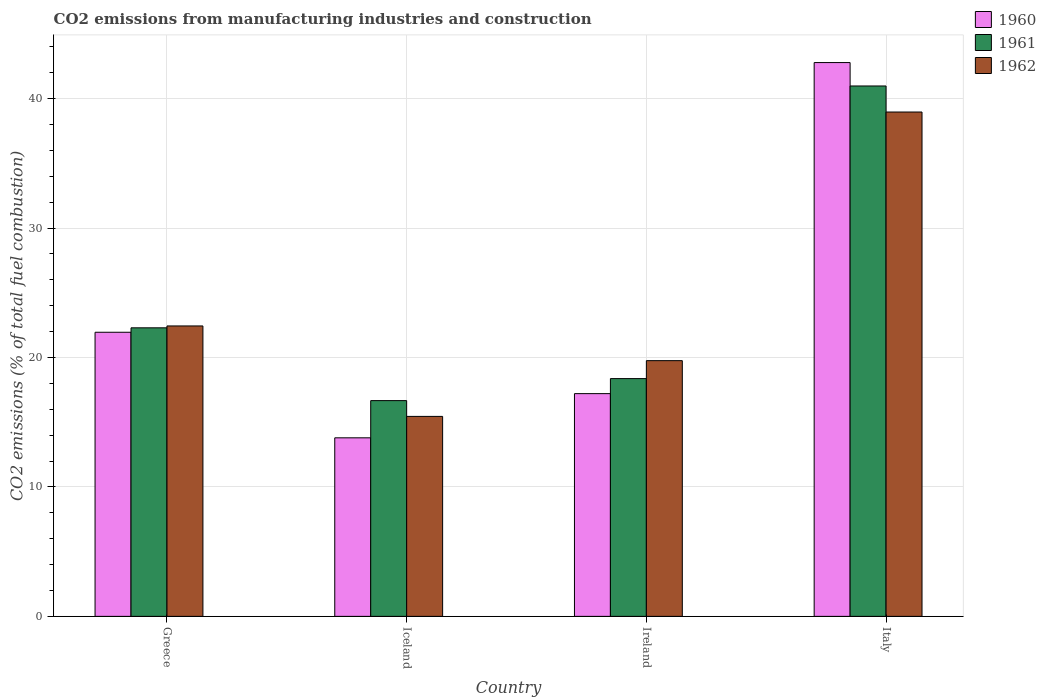How many different coloured bars are there?
Your answer should be very brief. 3. Are the number of bars per tick equal to the number of legend labels?
Give a very brief answer. Yes. Are the number of bars on each tick of the X-axis equal?
Your answer should be very brief. Yes. What is the label of the 2nd group of bars from the left?
Give a very brief answer. Iceland. What is the amount of CO2 emitted in 1960 in Greece?
Your answer should be very brief. 21.95. Across all countries, what is the maximum amount of CO2 emitted in 1960?
Keep it short and to the point. 42.78. Across all countries, what is the minimum amount of CO2 emitted in 1961?
Keep it short and to the point. 16.67. In which country was the amount of CO2 emitted in 1960 maximum?
Keep it short and to the point. Italy. In which country was the amount of CO2 emitted in 1962 minimum?
Your response must be concise. Iceland. What is the total amount of CO2 emitted in 1960 in the graph?
Ensure brevity in your answer.  95.73. What is the difference between the amount of CO2 emitted in 1960 in Iceland and that in Italy?
Make the answer very short. -28.99. What is the difference between the amount of CO2 emitted in 1960 in Italy and the amount of CO2 emitted in 1961 in Iceland?
Provide a succinct answer. 26.12. What is the average amount of CO2 emitted in 1961 per country?
Offer a terse response. 24.57. What is the difference between the amount of CO2 emitted of/in 1961 and amount of CO2 emitted of/in 1960 in Greece?
Your answer should be very brief. 0.34. What is the ratio of the amount of CO2 emitted in 1962 in Greece to that in Italy?
Keep it short and to the point. 0.58. Is the amount of CO2 emitted in 1962 in Ireland less than that in Italy?
Your answer should be very brief. Yes. Is the difference between the amount of CO2 emitted in 1961 in Greece and Italy greater than the difference between the amount of CO2 emitted in 1960 in Greece and Italy?
Your response must be concise. Yes. What is the difference between the highest and the second highest amount of CO2 emitted in 1961?
Offer a very short reply. 22.61. What is the difference between the highest and the lowest amount of CO2 emitted in 1962?
Offer a terse response. 23.51. Is the sum of the amount of CO2 emitted in 1961 in Greece and Iceland greater than the maximum amount of CO2 emitted in 1960 across all countries?
Ensure brevity in your answer.  No. What does the 3rd bar from the left in Ireland represents?
Your answer should be compact. 1962. How many bars are there?
Make the answer very short. 12. Are all the bars in the graph horizontal?
Offer a very short reply. No. Does the graph contain grids?
Offer a very short reply. Yes. Where does the legend appear in the graph?
Offer a very short reply. Top right. How many legend labels are there?
Ensure brevity in your answer.  3. How are the legend labels stacked?
Your response must be concise. Vertical. What is the title of the graph?
Your answer should be compact. CO2 emissions from manufacturing industries and construction. Does "2011" appear as one of the legend labels in the graph?
Your response must be concise. No. What is the label or title of the Y-axis?
Offer a very short reply. CO2 emissions (% of total fuel combustion). What is the CO2 emissions (% of total fuel combustion) of 1960 in Greece?
Your answer should be very brief. 21.95. What is the CO2 emissions (% of total fuel combustion) in 1961 in Greece?
Make the answer very short. 22.29. What is the CO2 emissions (% of total fuel combustion) in 1962 in Greece?
Ensure brevity in your answer.  22.44. What is the CO2 emissions (% of total fuel combustion) in 1960 in Iceland?
Your answer should be compact. 13.79. What is the CO2 emissions (% of total fuel combustion) of 1961 in Iceland?
Give a very brief answer. 16.67. What is the CO2 emissions (% of total fuel combustion) in 1962 in Iceland?
Provide a short and direct response. 15.45. What is the CO2 emissions (% of total fuel combustion) in 1960 in Ireland?
Offer a very short reply. 17.21. What is the CO2 emissions (% of total fuel combustion) in 1961 in Ireland?
Ensure brevity in your answer.  18.37. What is the CO2 emissions (% of total fuel combustion) in 1962 in Ireland?
Your response must be concise. 19.75. What is the CO2 emissions (% of total fuel combustion) of 1960 in Italy?
Make the answer very short. 42.78. What is the CO2 emissions (% of total fuel combustion) of 1961 in Italy?
Provide a short and direct response. 40.97. What is the CO2 emissions (% of total fuel combustion) of 1962 in Italy?
Ensure brevity in your answer.  38.96. Across all countries, what is the maximum CO2 emissions (% of total fuel combustion) of 1960?
Offer a terse response. 42.78. Across all countries, what is the maximum CO2 emissions (% of total fuel combustion) of 1961?
Provide a succinct answer. 40.97. Across all countries, what is the maximum CO2 emissions (% of total fuel combustion) of 1962?
Give a very brief answer. 38.96. Across all countries, what is the minimum CO2 emissions (% of total fuel combustion) in 1960?
Offer a very short reply. 13.79. Across all countries, what is the minimum CO2 emissions (% of total fuel combustion) in 1961?
Your answer should be very brief. 16.67. Across all countries, what is the minimum CO2 emissions (% of total fuel combustion) in 1962?
Keep it short and to the point. 15.45. What is the total CO2 emissions (% of total fuel combustion) in 1960 in the graph?
Your response must be concise. 95.73. What is the total CO2 emissions (% of total fuel combustion) in 1961 in the graph?
Offer a terse response. 98.3. What is the total CO2 emissions (% of total fuel combustion) of 1962 in the graph?
Your answer should be compact. 96.6. What is the difference between the CO2 emissions (% of total fuel combustion) of 1960 in Greece and that in Iceland?
Your response must be concise. 8.15. What is the difference between the CO2 emissions (% of total fuel combustion) in 1961 in Greece and that in Iceland?
Your response must be concise. 5.62. What is the difference between the CO2 emissions (% of total fuel combustion) in 1962 in Greece and that in Iceland?
Your answer should be very brief. 6.99. What is the difference between the CO2 emissions (% of total fuel combustion) in 1960 in Greece and that in Ireland?
Provide a short and direct response. 4.74. What is the difference between the CO2 emissions (% of total fuel combustion) in 1961 in Greece and that in Ireland?
Offer a terse response. 3.92. What is the difference between the CO2 emissions (% of total fuel combustion) in 1962 in Greece and that in Ireland?
Offer a terse response. 2.68. What is the difference between the CO2 emissions (% of total fuel combustion) of 1960 in Greece and that in Italy?
Your answer should be very brief. -20.83. What is the difference between the CO2 emissions (% of total fuel combustion) of 1961 in Greece and that in Italy?
Provide a succinct answer. -18.68. What is the difference between the CO2 emissions (% of total fuel combustion) of 1962 in Greece and that in Italy?
Your response must be concise. -16.53. What is the difference between the CO2 emissions (% of total fuel combustion) of 1960 in Iceland and that in Ireland?
Your response must be concise. -3.41. What is the difference between the CO2 emissions (% of total fuel combustion) in 1961 in Iceland and that in Ireland?
Ensure brevity in your answer.  -1.7. What is the difference between the CO2 emissions (% of total fuel combustion) of 1962 in Iceland and that in Ireland?
Provide a short and direct response. -4.31. What is the difference between the CO2 emissions (% of total fuel combustion) in 1960 in Iceland and that in Italy?
Your answer should be very brief. -28.99. What is the difference between the CO2 emissions (% of total fuel combustion) of 1961 in Iceland and that in Italy?
Your response must be concise. -24.31. What is the difference between the CO2 emissions (% of total fuel combustion) of 1962 in Iceland and that in Italy?
Keep it short and to the point. -23.51. What is the difference between the CO2 emissions (% of total fuel combustion) of 1960 in Ireland and that in Italy?
Your answer should be very brief. -25.57. What is the difference between the CO2 emissions (% of total fuel combustion) of 1961 in Ireland and that in Italy?
Your response must be concise. -22.61. What is the difference between the CO2 emissions (% of total fuel combustion) of 1962 in Ireland and that in Italy?
Your answer should be compact. -19.21. What is the difference between the CO2 emissions (% of total fuel combustion) of 1960 in Greece and the CO2 emissions (% of total fuel combustion) of 1961 in Iceland?
Offer a terse response. 5.28. What is the difference between the CO2 emissions (% of total fuel combustion) of 1960 in Greece and the CO2 emissions (% of total fuel combustion) of 1962 in Iceland?
Make the answer very short. 6.5. What is the difference between the CO2 emissions (% of total fuel combustion) of 1961 in Greece and the CO2 emissions (% of total fuel combustion) of 1962 in Iceland?
Your answer should be very brief. 6.84. What is the difference between the CO2 emissions (% of total fuel combustion) in 1960 in Greece and the CO2 emissions (% of total fuel combustion) in 1961 in Ireland?
Your answer should be very brief. 3.58. What is the difference between the CO2 emissions (% of total fuel combustion) of 1960 in Greece and the CO2 emissions (% of total fuel combustion) of 1962 in Ireland?
Offer a very short reply. 2.19. What is the difference between the CO2 emissions (% of total fuel combustion) of 1961 in Greece and the CO2 emissions (% of total fuel combustion) of 1962 in Ireland?
Give a very brief answer. 2.54. What is the difference between the CO2 emissions (% of total fuel combustion) in 1960 in Greece and the CO2 emissions (% of total fuel combustion) in 1961 in Italy?
Provide a succinct answer. -19.03. What is the difference between the CO2 emissions (% of total fuel combustion) in 1960 in Greece and the CO2 emissions (% of total fuel combustion) in 1962 in Italy?
Offer a very short reply. -17.01. What is the difference between the CO2 emissions (% of total fuel combustion) in 1961 in Greece and the CO2 emissions (% of total fuel combustion) in 1962 in Italy?
Give a very brief answer. -16.67. What is the difference between the CO2 emissions (% of total fuel combustion) in 1960 in Iceland and the CO2 emissions (% of total fuel combustion) in 1961 in Ireland?
Provide a short and direct response. -4.57. What is the difference between the CO2 emissions (% of total fuel combustion) in 1960 in Iceland and the CO2 emissions (% of total fuel combustion) in 1962 in Ireland?
Give a very brief answer. -5.96. What is the difference between the CO2 emissions (% of total fuel combustion) in 1961 in Iceland and the CO2 emissions (% of total fuel combustion) in 1962 in Ireland?
Give a very brief answer. -3.09. What is the difference between the CO2 emissions (% of total fuel combustion) of 1960 in Iceland and the CO2 emissions (% of total fuel combustion) of 1961 in Italy?
Offer a terse response. -27.18. What is the difference between the CO2 emissions (% of total fuel combustion) in 1960 in Iceland and the CO2 emissions (% of total fuel combustion) in 1962 in Italy?
Make the answer very short. -25.17. What is the difference between the CO2 emissions (% of total fuel combustion) in 1961 in Iceland and the CO2 emissions (% of total fuel combustion) in 1962 in Italy?
Give a very brief answer. -22.29. What is the difference between the CO2 emissions (% of total fuel combustion) in 1960 in Ireland and the CO2 emissions (% of total fuel combustion) in 1961 in Italy?
Keep it short and to the point. -23.77. What is the difference between the CO2 emissions (% of total fuel combustion) of 1960 in Ireland and the CO2 emissions (% of total fuel combustion) of 1962 in Italy?
Make the answer very short. -21.75. What is the difference between the CO2 emissions (% of total fuel combustion) in 1961 in Ireland and the CO2 emissions (% of total fuel combustion) in 1962 in Italy?
Give a very brief answer. -20.59. What is the average CO2 emissions (% of total fuel combustion) in 1960 per country?
Provide a short and direct response. 23.93. What is the average CO2 emissions (% of total fuel combustion) in 1961 per country?
Ensure brevity in your answer.  24.57. What is the average CO2 emissions (% of total fuel combustion) of 1962 per country?
Make the answer very short. 24.15. What is the difference between the CO2 emissions (% of total fuel combustion) of 1960 and CO2 emissions (% of total fuel combustion) of 1961 in Greece?
Offer a terse response. -0.34. What is the difference between the CO2 emissions (% of total fuel combustion) in 1960 and CO2 emissions (% of total fuel combustion) in 1962 in Greece?
Your answer should be compact. -0.49. What is the difference between the CO2 emissions (% of total fuel combustion) in 1961 and CO2 emissions (% of total fuel combustion) in 1962 in Greece?
Offer a terse response. -0.15. What is the difference between the CO2 emissions (% of total fuel combustion) of 1960 and CO2 emissions (% of total fuel combustion) of 1961 in Iceland?
Keep it short and to the point. -2.87. What is the difference between the CO2 emissions (% of total fuel combustion) in 1960 and CO2 emissions (% of total fuel combustion) in 1962 in Iceland?
Give a very brief answer. -1.65. What is the difference between the CO2 emissions (% of total fuel combustion) of 1961 and CO2 emissions (% of total fuel combustion) of 1962 in Iceland?
Keep it short and to the point. 1.22. What is the difference between the CO2 emissions (% of total fuel combustion) of 1960 and CO2 emissions (% of total fuel combustion) of 1961 in Ireland?
Provide a short and direct response. -1.16. What is the difference between the CO2 emissions (% of total fuel combustion) of 1960 and CO2 emissions (% of total fuel combustion) of 1962 in Ireland?
Provide a succinct answer. -2.55. What is the difference between the CO2 emissions (% of total fuel combustion) in 1961 and CO2 emissions (% of total fuel combustion) in 1962 in Ireland?
Offer a terse response. -1.39. What is the difference between the CO2 emissions (% of total fuel combustion) of 1960 and CO2 emissions (% of total fuel combustion) of 1961 in Italy?
Make the answer very short. 1.81. What is the difference between the CO2 emissions (% of total fuel combustion) in 1960 and CO2 emissions (% of total fuel combustion) in 1962 in Italy?
Keep it short and to the point. 3.82. What is the difference between the CO2 emissions (% of total fuel combustion) in 1961 and CO2 emissions (% of total fuel combustion) in 1962 in Italy?
Make the answer very short. 2.01. What is the ratio of the CO2 emissions (% of total fuel combustion) of 1960 in Greece to that in Iceland?
Ensure brevity in your answer.  1.59. What is the ratio of the CO2 emissions (% of total fuel combustion) in 1961 in Greece to that in Iceland?
Your answer should be very brief. 1.34. What is the ratio of the CO2 emissions (% of total fuel combustion) of 1962 in Greece to that in Iceland?
Your answer should be very brief. 1.45. What is the ratio of the CO2 emissions (% of total fuel combustion) of 1960 in Greece to that in Ireland?
Provide a succinct answer. 1.28. What is the ratio of the CO2 emissions (% of total fuel combustion) of 1961 in Greece to that in Ireland?
Make the answer very short. 1.21. What is the ratio of the CO2 emissions (% of total fuel combustion) of 1962 in Greece to that in Ireland?
Your answer should be compact. 1.14. What is the ratio of the CO2 emissions (% of total fuel combustion) of 1960 in Greece to that in Italy?
Your answer should be very brief. 0.51. What is the ratio of the CO2 emissions (% of total fuel combustion) in 1961 in Greece to that in Italy?
Your answer should be very brief. 0.54. What is the ratio of the CO2 emissions (% of total fuel combustion) of 1962 in Greece to that in Italy?
Give a very brief answer. 0.58. What is the ratio of the CO2 emissions (% of total fuel combustion) in 1960 in Iceland to that in Ireland?
Make the answer very short. 0.8. What is the ratio of the CO2 emissions (% of total fuel combustion) of 1961 in Iceland to that in Ireland?
Your answer should be compact. 0.91. What is the ratio of the CO2 emissions (% of total fuel combustion) of 1962 in Iceland to that in Ireland?
Keep it short and to the point. 0.78. What is the ratio of the CO2 emissions (% of total fuel combustion) of 1960 in Iceland to that in Italy?
Provide a short and direct response. 0.32. What is the ratio of the CO2 emissions (% of total fuel combustion) in 1961 in Iceland to that in Italy?
Offer a terse response. 0.41. What is the ratio of the CO2 emissions (% of total fuel combustion) in 1962 in Iceland to that in Italy?
Give a very brief answer. 0.4. What is the ratio of the CO2 emissions (% of total fuel combustion) in 1960 in Ireland to that in Italy?
Your answer should be compact. 0.4. What is the ratio of the CO2 emissions (% of total fuel combustion) of 1961 in Ireland to that in Italy?
Your answer should be very brief. 0.45. What is the ratio of the CO2 emissions (% of total fuel combustion) of 1962 in Ireland to that in Italy?
Provide a succinct answer. 0.51. What is the difference between the highest and the second highest CO2 emissions (% of total fuel combustion) of 1960?
Ensure brevity in your answer.  20.83. What is the difference between the highest and the second highest CO2 emissions (% of total fuel combustion) of 1961?
Your answer should be very brief. 18.68. What is the difference between the highest and the second highest CO2 emissions (% of total fuel combustion) in 1962?
Provide a succinct answer. 16.53. What is the difference between the highest and the lowest CO2 emissions (% of total fuel combustion) of 1960?
Your answer should be compact. 28.99. What is the difference between the highest and the lowest CO2 emissions (% of total fuel combustion) in 1961?
Your answer should be compact. 24.31. What is the difference between the highest and the lowest CO2 emissions (% of total fuel combustion) of 1962?
Your answer should be very brief. 23.51. 